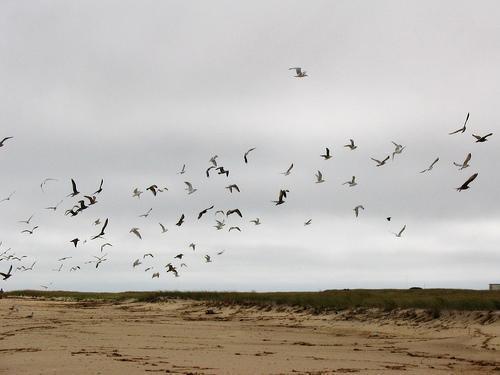How many buildings are there?
Give a very brief answer. 1. 